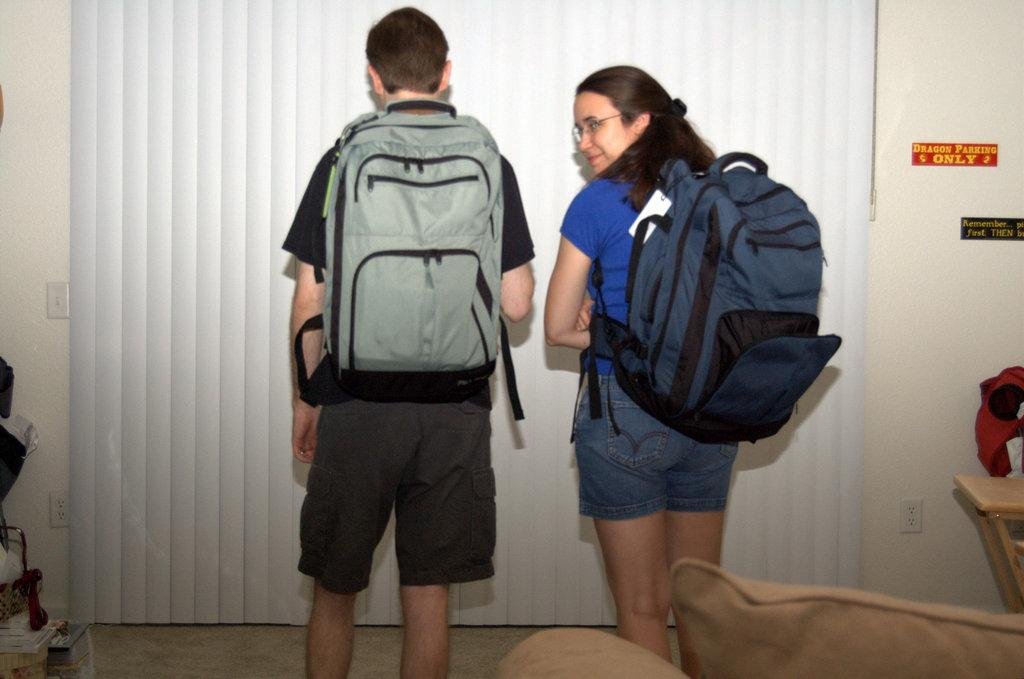<image>
Summarize the visual content of the image. A boy and girl wearing backpacks next to a sign that says "dragon parking only" 